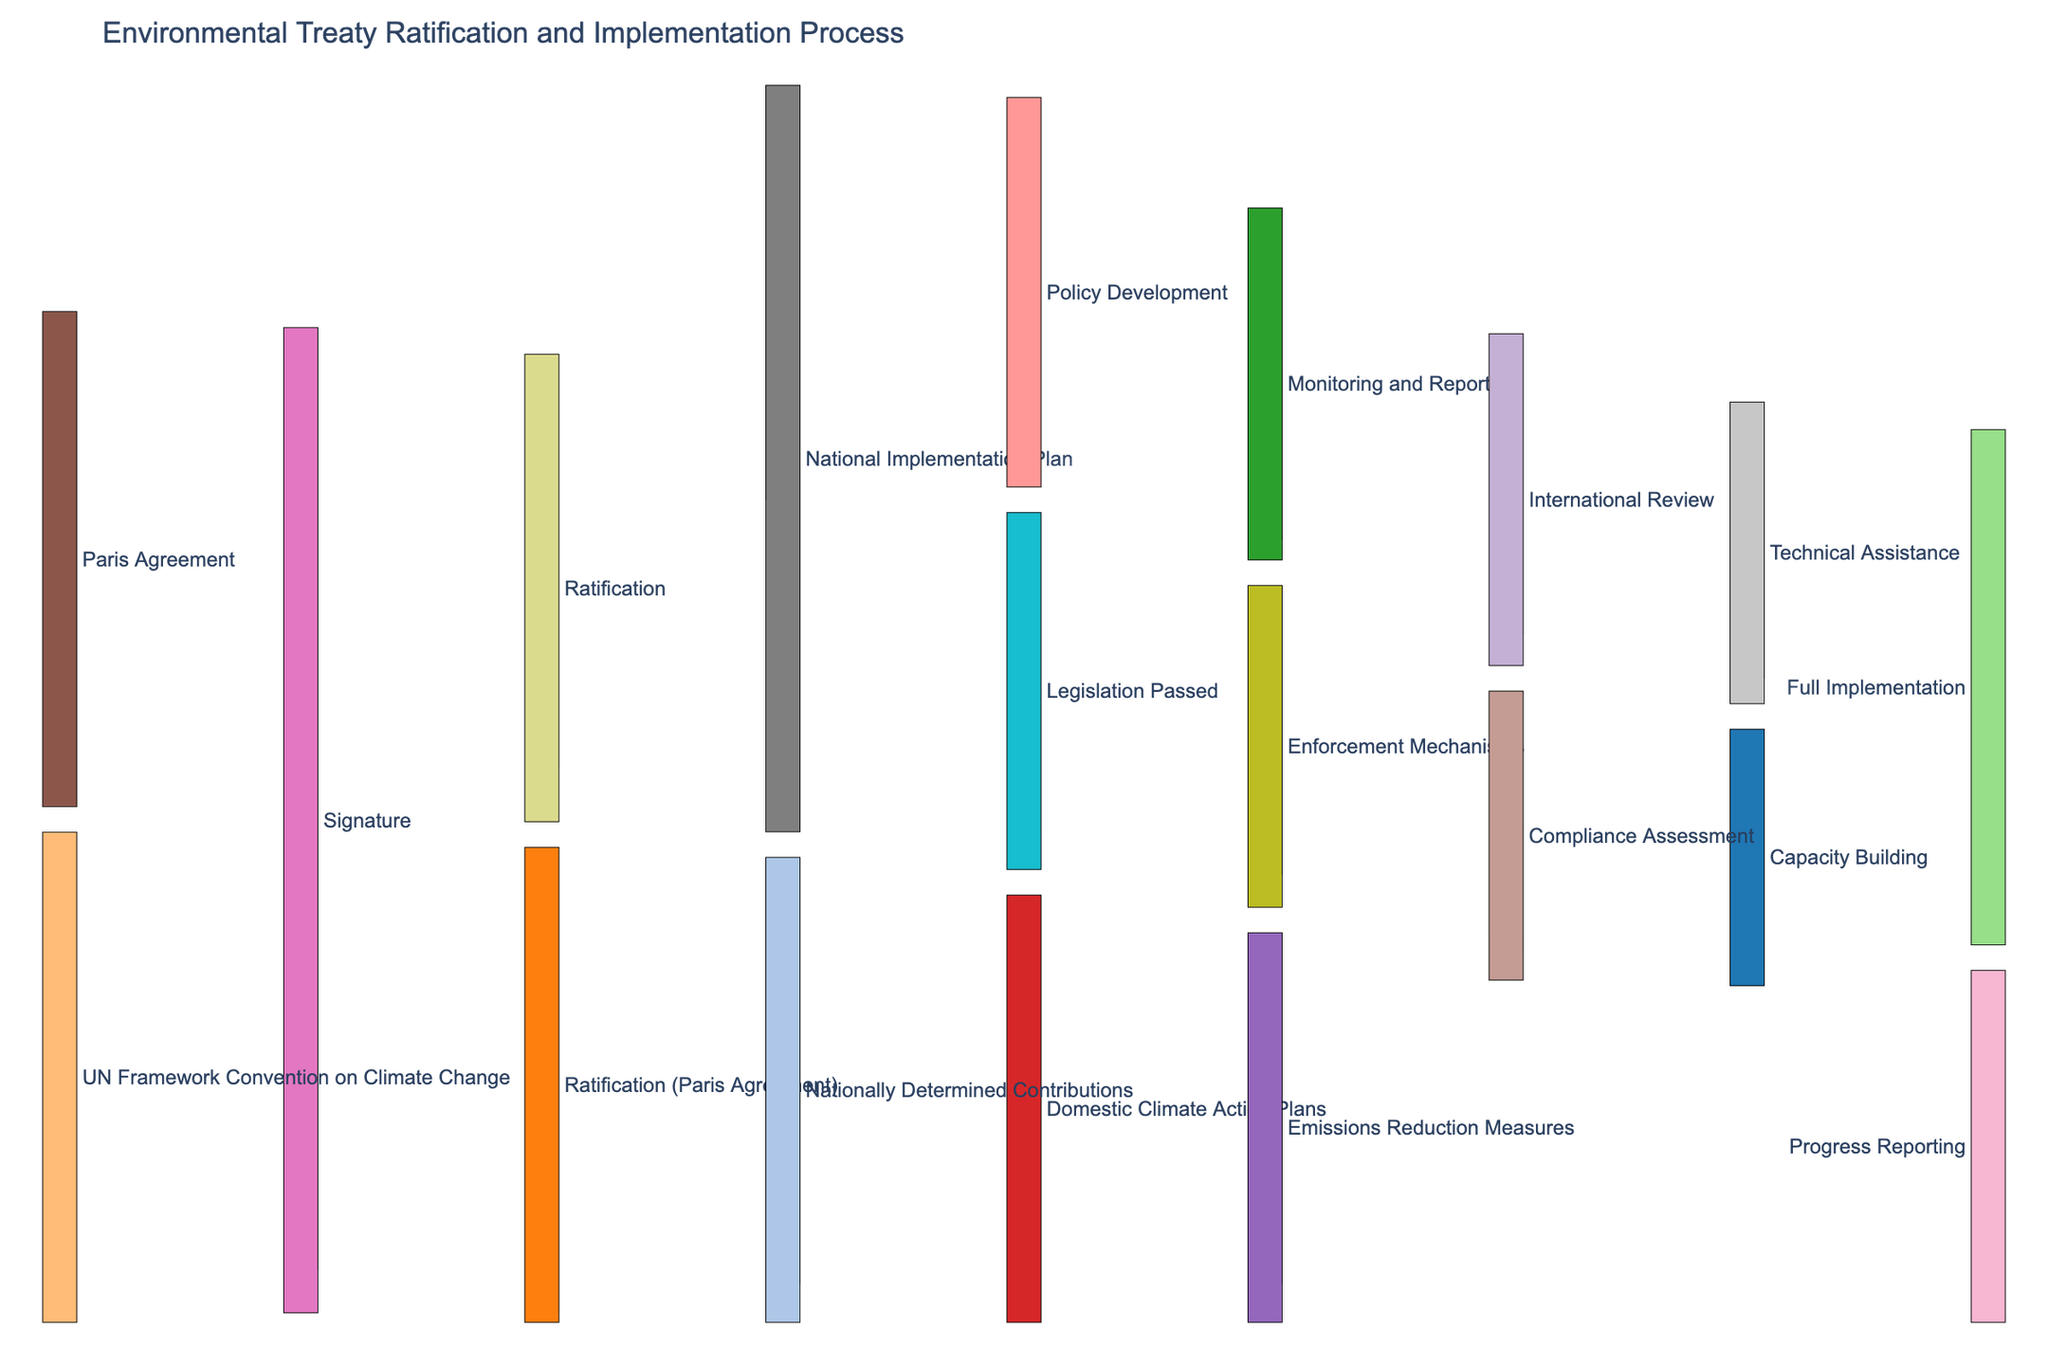question: What is the title of the figure? explanation: The title is usually displayed prominently at the top of the figure. By looking at the top, we can read the title of the plot.
Answer: Environmental Treaty Ratification and Implementation Process question: How many countries have signed the UN Framework Convention on Climate Change? explanation: By identifying the source labeled "UN Framework Convention on Climate Change" and tracing the flow to its paired target "Signature," we can see the corresponding value for the flow.
Answer: 195 question: Which implementation stage has more countries involved, Policy Development or Legislation Passed? explanation: First, identify the flows labeled "National Implementation Plan" to "Policy Development" and to "Legislation Passed." Compare the values associated with these flows.
Answer: Policy Development question: What is the total number of countries reaching the Full Implementation stage? explanation: Add the values of flows leading to "Full Implementation" from both "Capacity Building" and "Technical Assistance." By summing, we find the total.
Answer: 205 question: What is the smallest flow value in the chart and its associated stages? explanation: Review all the flow values provided in the data. Identify the smallest value and its associated stages where this transition occurs.
Answer: 0, Ratification to Nationally Determined Contributions question: How many countries have moved from the Ratification stage to the National Implementation Plan stage? explanation: Identify the flow labeled "Ratification" to "National Implementation Plan" and note the corresponding value.
Answer: 165 question: Is there a higher number of countries progressing from National Implementation Plan to Monitoring and Reporting or from Domestic Climate Action Plans to Progress Reporting? explanation: Compare the values of flows from "National Implementation Plan" to "Monitoring and Reporting" and from "Domestic Climate Action Plans" to "Progress Reporting."
Answer: National Implementation Plan to Monitoring and Reporting question: How many countries have signed the Paris Agreement? explanation: Find the flow labeled "Paris Agreement" to "Signature" and note the corresponding value.
Answer: 197 question: What is the number of countries that have reached Enforcement Mechanisms stage? explanation: Find the flow labeled "Legislation Passed" to "Enforcement Mechanisms" and note the corresponding value.
Answer: 128 question: How many stages are involved in the National Implementation Plan process after Ratification? explanation: Trace the stages starting from "National Implementation Plan," counting each distinct target node it connects to.
Answer: 5 